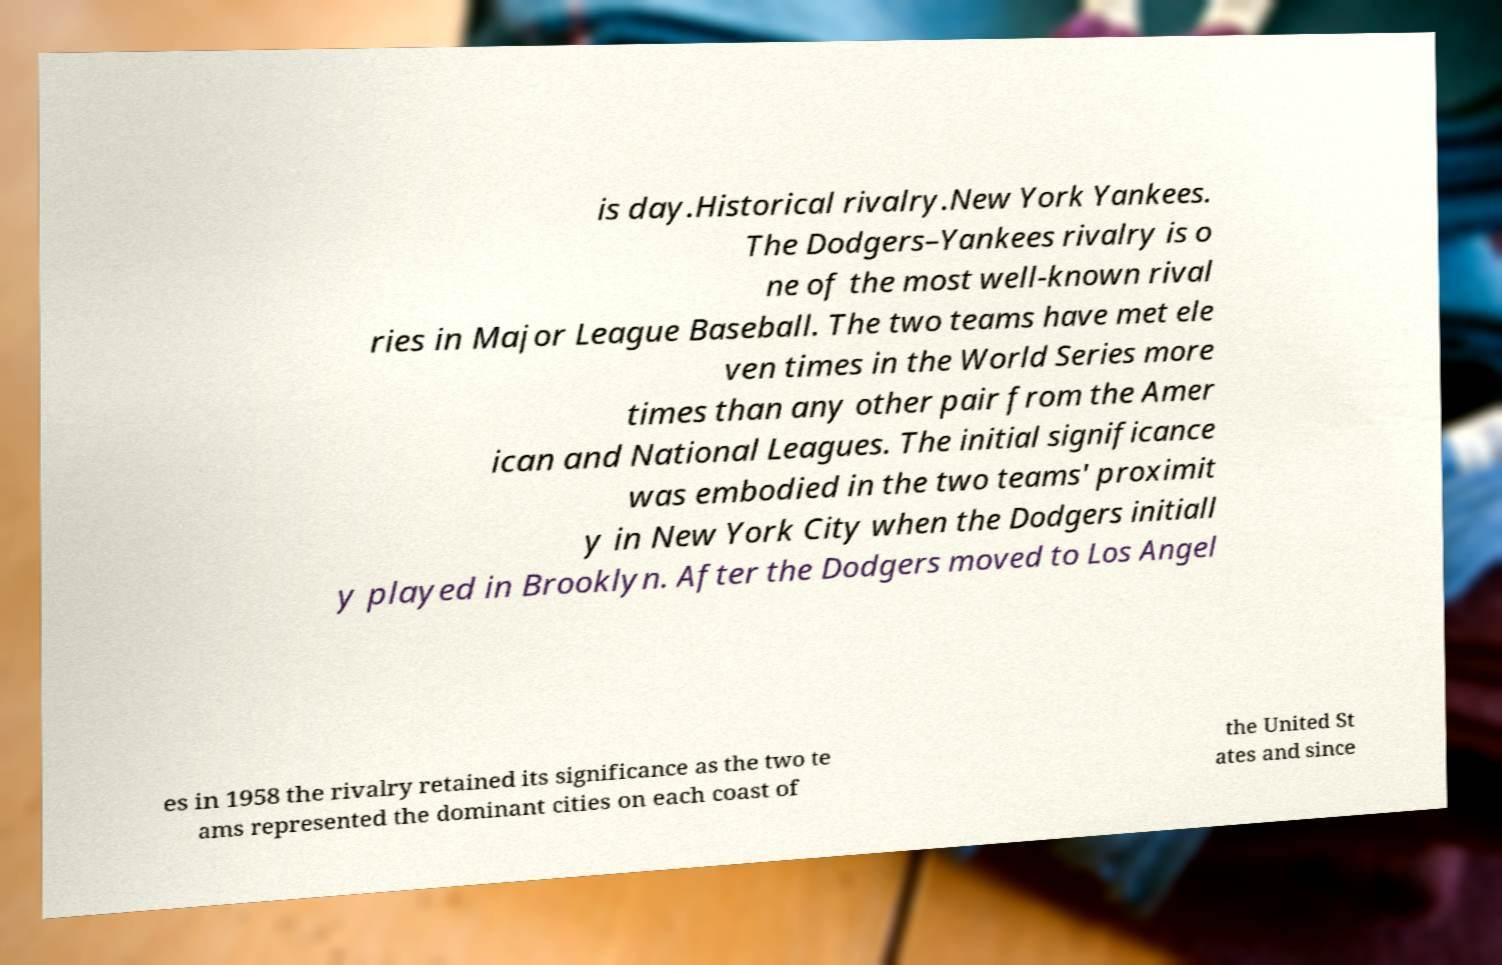Can you accurately transcribe the text from the provided image for me? is day.Historical rivalry.New York Yankees. The Dodgers–Yankees rivalry is o ne of the most well-known rival ries in Major League Baseball. The two teams have met ele ven times in the World Series more times than any other pair from the Amer ican and National Leagues. The initial significance was embodied in the two teams' proximit y in New York City when the Dodgers initiall y played in Brooklyn. After the Dodgers moved to Los Angel es in 1958 the rivalry retained its significance as the two te ams represented the dominant cities on each coast of the United St ates and since 